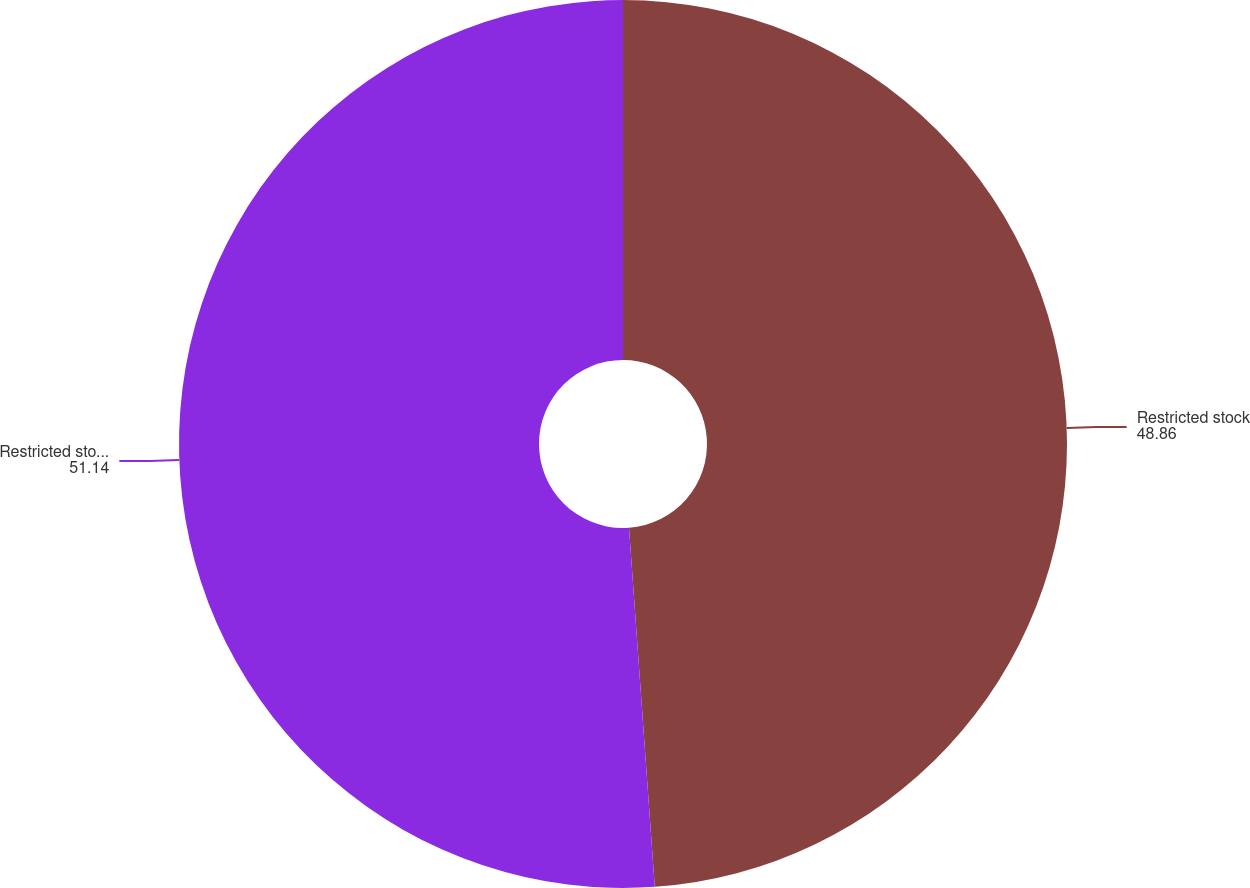<chart> <loc_0><loc_0><loc_500><loc_500><pie_chart><fcel>Restricted stock<fcel>Restricted stock units<nl><fcel>48.86%<fcel>51.14%<nl></chart> 